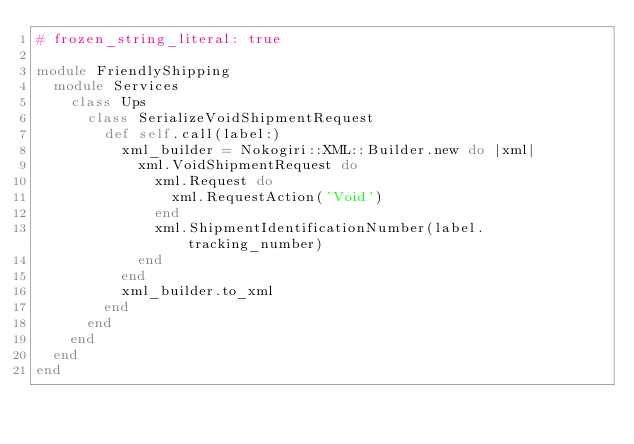Convert code to text. <code><loc_0><loc_0><loc_500><loc_500><_Ruby_># frozen_string_literal: true

module FriendlyShipping
  module Services
    class Ups
      class SerializeVoidShipmentRequest
        def self.call(label:)
          xml_builder = Nokogiri::XML::Builder.new do |xml|
            xml.VoidShipmentRequest do
              xml.Request do
                xml.RequestAction('Void')
              end
              xml.ShipmentIdentificationNumber(label.tracking_number)
            end
          end
          xml_builder.to_xml
        end
      end
    end
  end
end
</code> 